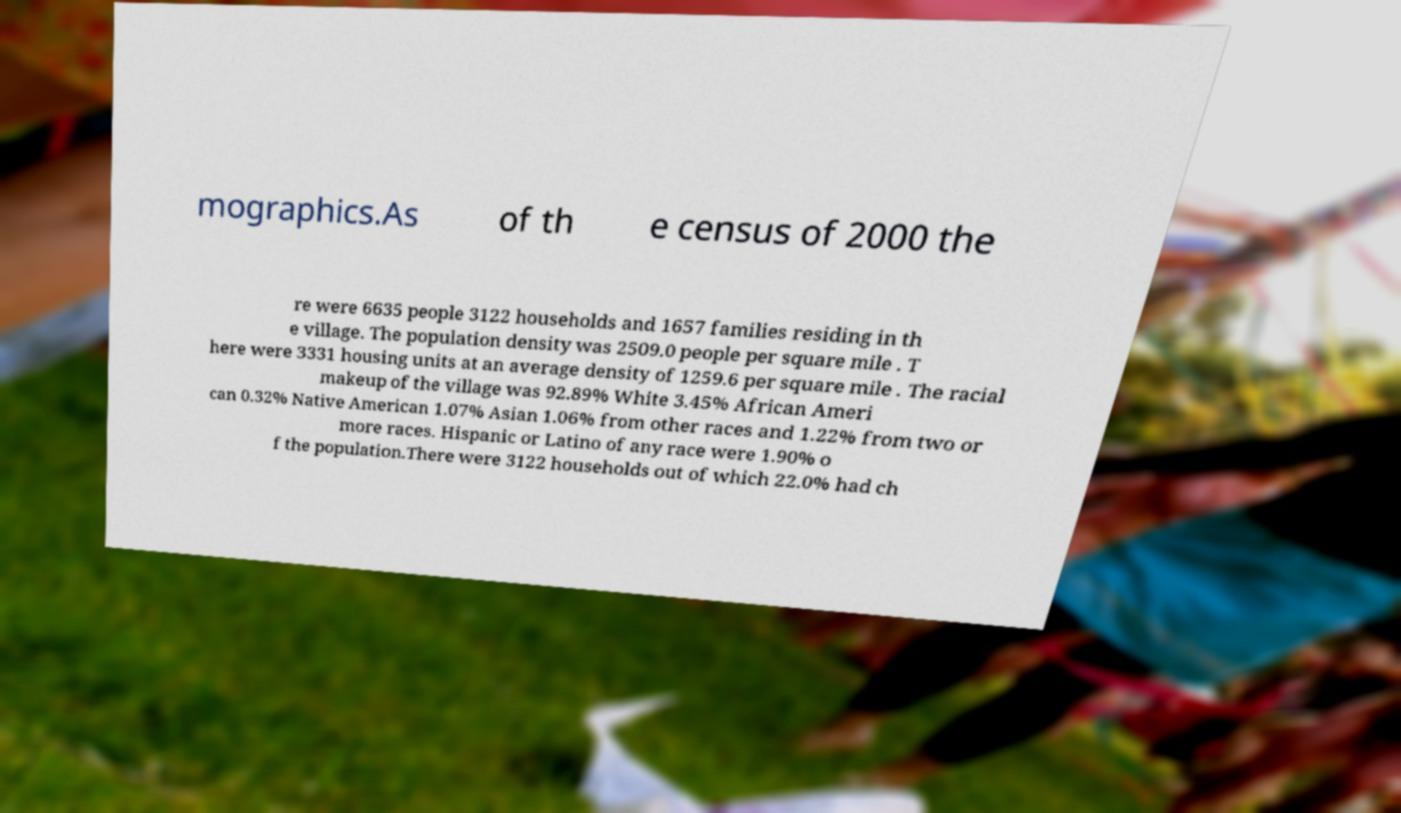There's text embedded in this image that I need extracted. Can you transcribe it verbatim? mographics.As of th e census of 2000 the re were 6635 people 3122 households and 1657 families residing in th e village. The population density was 2509.0 people per square mile . T here were 3331 housing units at an average density of 1259.6 per square mile . The racial makeup of the village was 92.89% White 3.45% African Ameri can 0.32% Native American 1.07% Asian 1.06% from other races and 1.22% from two or more races. Hispanic or Latino of any race were 1.90% o f the population.There were 3122 households out of which 22.0% had ch 